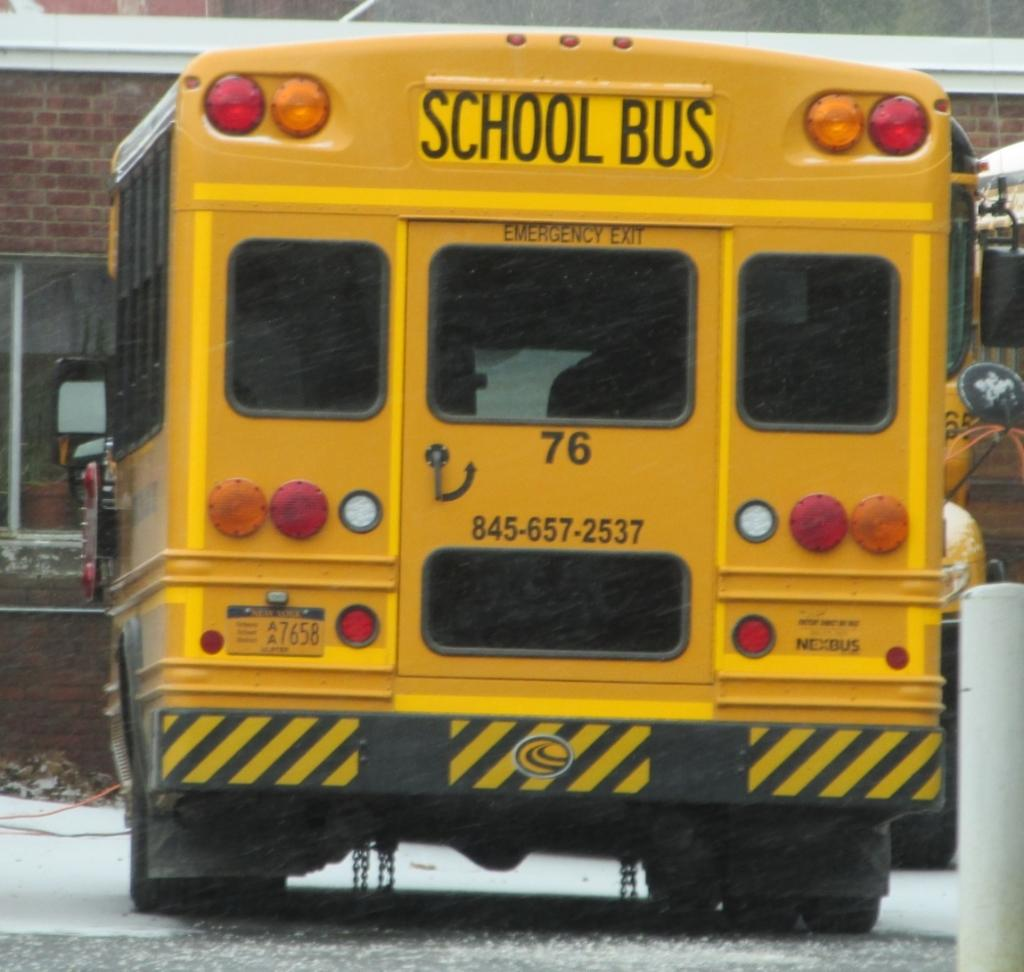What type of vehicle is in the image? There is a yellow bus in the image. What is written on the bus? The bus has "school bus" written on it. What can be seen behind the bus? There is a building behind the bus. What is the building made of? The building has a brick wall. What feature is present on the building? The building has windows. How many glasses are on the bus in the image? There are no glasses present on the bus in the image. 